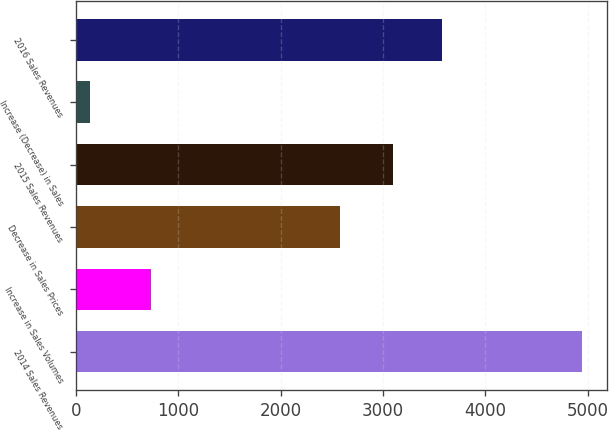Convert chart to OTSL. <chart><loc_0><loc_0><loc_500><loc_500><bar_chart><fcel>2014 Sales Revenues<fcel>Increase in Sales Volumes<fcel>Decrease in Sales Prices<fcel>2015 Sales Revenues<fcel>Increase (Decrease) in Sales<fcel>2016 Sales Revenues<nl><fcel>4945<fcel>728<fcel>2580<fcel>3093<fcel>131<fcel>3574.4<nl></chart> 